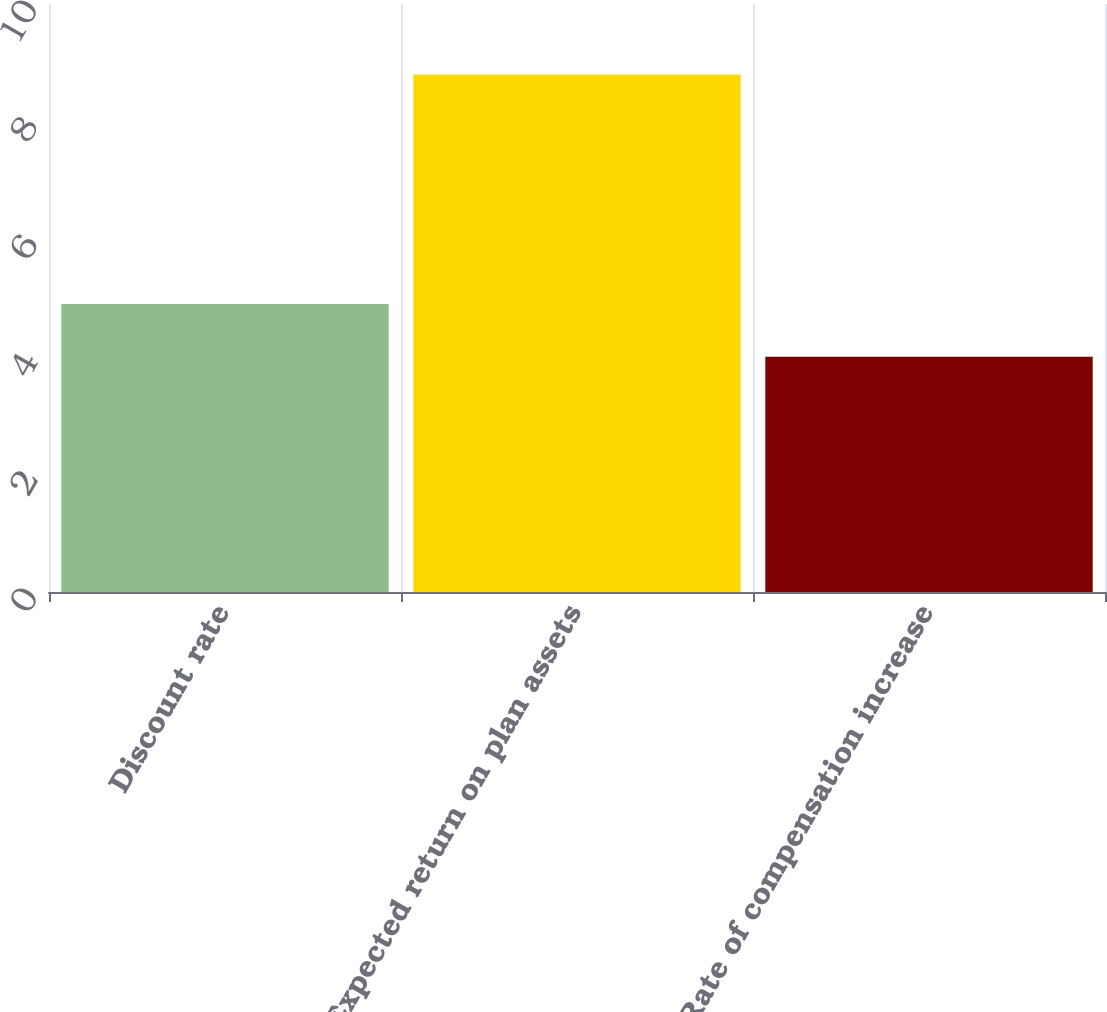Convert chart. <chart><loc_0><loc_0><loc_500><loc_500><bar_chart><fcel>Discount rate<fcel>Expected return on plan assets<fcel>Rate of compensation increase<nl><fcel>4.9<fcel>8.8<fcel>4<nl></chart> 